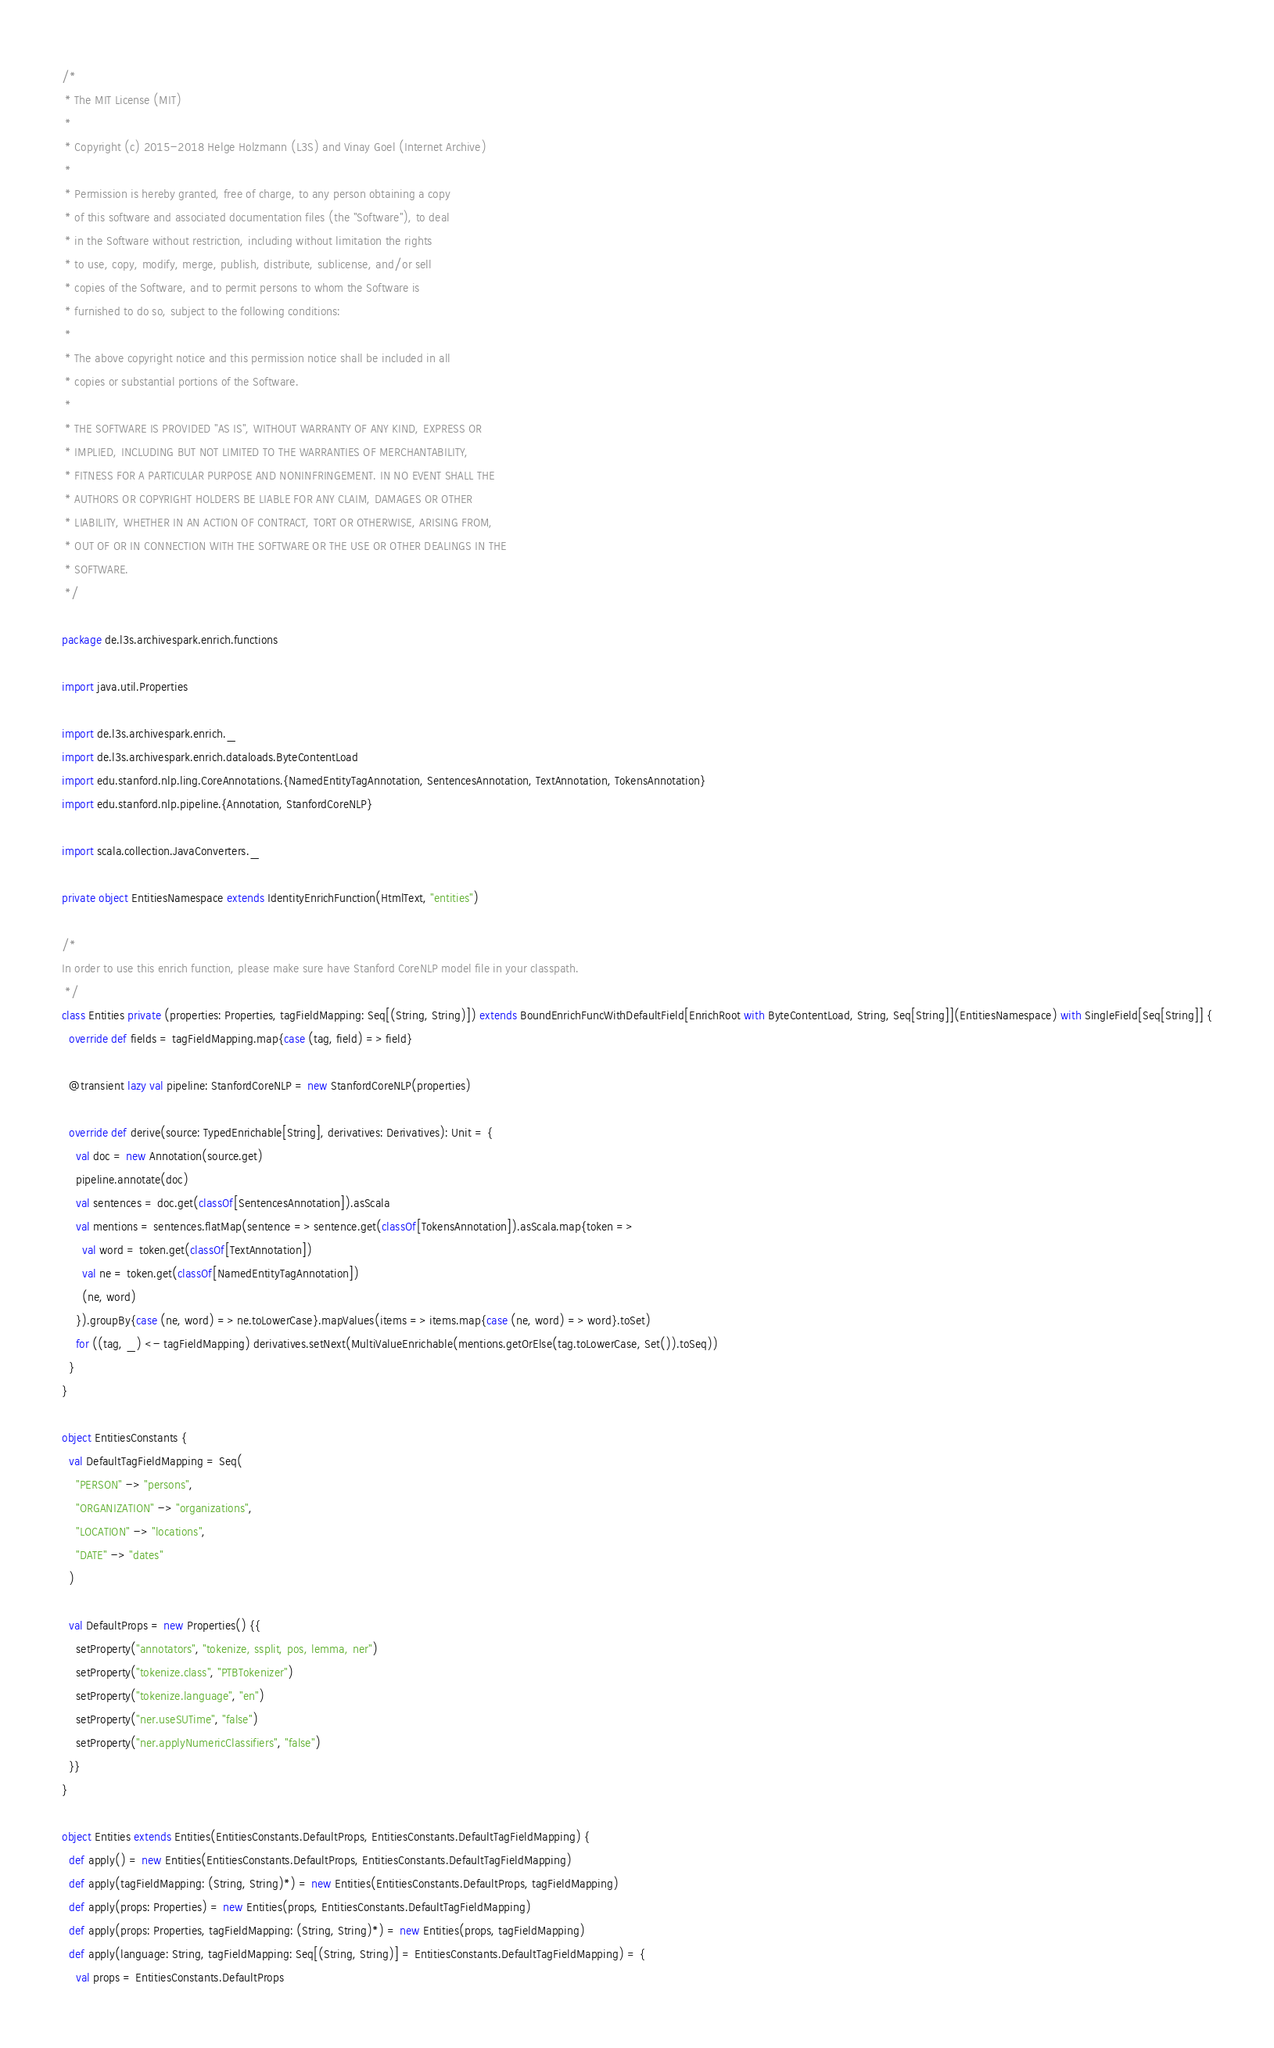<code> <loc_0><loc_0><loc_500><loc_500><_Scala_>/*
 * The MIT License (MIT)
 *
 * Copyright (c) 2015-2018 Helge Holzmann (L3S) and Vinay Goel (Internet Archive)
 *
 * Permission is hereby granted, free of charge, to any person obtaining a copy
 * of this software and associated documentation files (the "Software"), to deal
 * in the Software without restriction, including without limitation the rights
 * to use, copy, modify, merge, publish, distribute, sublicense, and/or sell
 * copies of the Software, and to permit persons to whom the Software is
 * furnished to do so, subject to the following conditions:
 *
 * The above copyright notice and this permission notice shall be included in all
 * copies or substantial portions of the Software.
 *
 * THE SOFTWARE IS PROVIDED "AS IS", WITHOUT WARRANTY OF ANY KIND, EXPRESS OR
 * IMPLIED, INCLUDING BUT NOT LIMITED TO THE WARRANTIES OF MERCHANTABILITY,
 * FITNESS FOR A PARTICULAR PURPOSE AND NONINFRINGEMENT. IN NO EVENT SHALL THE
 * AUTHORS OR COPYRIGHT HOLDERS BE LIABLE FOR ANY CLAIM, DAMAGES OR OTHER
 * LIABILITY, WHETHER IN AN ACTION OF CONTRACT, TORT OR OTHERWISE, ARISING FROM,
 * OUT OF OR IN CONNECTION WITH THE SOFTWARE OR THE USE OR OTHER DEALINGS IN THE
 * SOFTWARE.
 */

package de.l3s.archivespark.enrich.functions

import java.util.Properties

import de.l3s.archivespark.enrich._
import de.l3s.archivespark.enrich.dataloads.ByteContentLoad
import edu.stanford.nlp.ling.CoreAnnotations.{NamedEntityTagAnnotation, SentencesAnnotation, TextAnnotation, TokensAnnotation}
import edu.stanford.nlp.pipeline.{Annotation, StanfordCoreNLP}

import scala.collection.JavaConverters._

private object EntitiesNamespace extends IdentityEnrichFunction(HtmlText, "entities")

/*
In order to use this enrich function, please make sure have Stanford CoreNLP model file in your classpath.
 */
class Entities private (properties: Properties, tagFieldMapping: Seq[(String, String)]) extends BoundEnrichFuncWithDefaultField[EnrichRoot with ByteContentLoad, String, Seq[String]](EntitiesNamespace) with SingleField[Seq[String]] {
  override def fields = tagFieldMapping.map{case (tag, field) => field}

  @transient lazy val pipeline: StanfordCoreNLP = new StanfordCoreNLP(properties)

  override def derive(source: TypedEnrichable[String], derivatives: Derivatives): Unit = {
    val doc = new Annotation(source.get)
    pipeline.annotate(doc)
    val sentences = doc.get(classOf[SentencesAnnotation]).asScala
    val mentions = sentences.flatMap(sentence => sentence.get(classOf[TokensAnnotation]).asScala.map{token =>
      val word = token.get(classOf[TextAnnotation])
      val ne = token.get(classOf[NamedEntityTagAnnotation])
      (ne, word)
    }).groupBy{case (ne, word) => ne.toLowerCase}.mapValues(items => items.map{case (ne, word) => word}.toSet)
    for ((tag, _) <- tagFieldMapping) derivatives.setNext(MultiValueEnrichable(mentions.getOrElse(tag.toLowerCase, Set()).toSeq))
  }
}

object EntitiesConstants {
  val DefaultTagFieldMapping = Seq(
    "PERSON" -> "persons",
    "ORGANIZATION" -> "organizations",
    "LOCATION" -> "locations",
    "DATE" -> "dates"
  )

  val DefaultProps = new Properties() {{
    setProperty("annotators", "tokenize, ssplit, pos, lemma, ner")
    setProperty("tokenize.class", "PTBTokenizer")
    setProperty("tokenize.language", "en")
    setProperty("ner.useSUTime", "false")
    setProperty("ner.applyNumericClassifiers", "false")
  }}
}

object Entities extends Entities(EntitiesConstants.DefaultProps, EntitiesConstants.DefaultTagFieldMapping) {
  def apply() = new Entities(EntitiesConstants.DefaultProps, EntitiesConstants.DefaultTagFieldMapping)
  def apply(tagFieldMapping: (String, String)*) = new Entities(EntitiesConstants.DefaultProps, tagFieldMapping)
  def apply(props: Properties) = new Entities(props, EntitiesConstants.DefaultTagFieldMapping)
  def apply(props: Properties, tagFieldMapping: (String, String)*) = new Entities(props, tagFieldMapping)
  def apply(language: String, tagFieldMapping: Seq[(String, String)] = EntitiesConstants.DefaultTagFieldMapping) = {
    val props = EntitiesConstants.DefaultProps</code> 